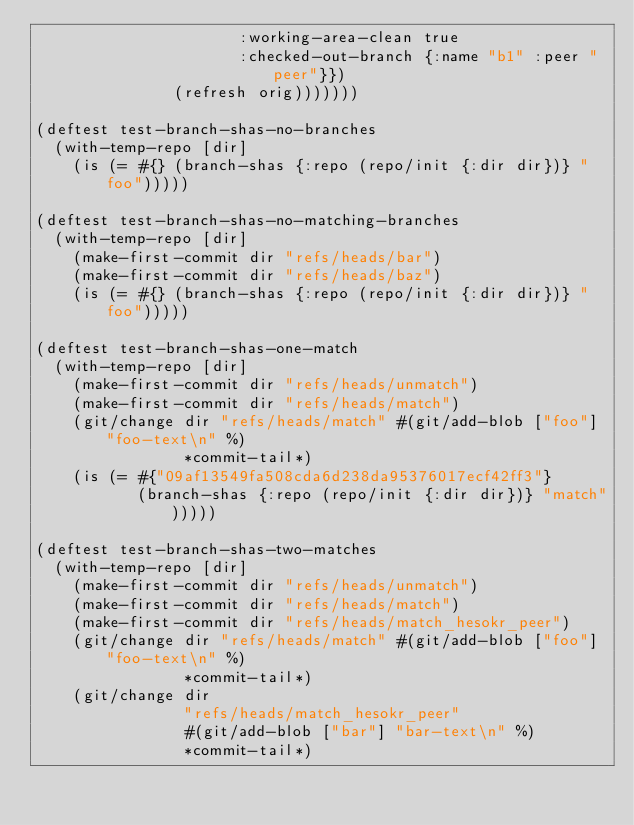Convert code to text. <code><loc_0><loc_0><loc_500><loc_500><_Clojure_>                      :working-area-clean true
                      :checked-out-branch {:name "b1" :peer "peer"}})
               (refresh orig)))))))

(deftest test-branch-shas-no-branches
  (with-temp-repo [dir]
    (is (= #{} (branch-shas {:repo (repo/init {:dir dir})} "foo")))))

(deftest test-branch-shas-no-matching-branches
  (with-temp-repo [dir]
    (make-first-commit dir "refs/heads/bar")
    (make-first-commit dir "refs/heads/baz")
    (is (= #{} (branch-shas {:repo (repo/init {:dir dir})} "foo")))))

(deftest test-branch-shas-one-match
  (with-temp-repo [dir]
    (make-first-commit dir "refs/heads/unmatch")
    (make-first-commit dir "refs/heads/match")
    (git/change dir "refs/heads/match" #(git/add-blob ["foo"] "foo-text\n" %)
                *commit-tail*)
    (is (= #{"09af13549fa508cda6d238da95376017ecf42ff3"}
           (branch-shas {:repo (repo/init {:dir dir})} "match")))))

(deftest test-branch-shas-two-matches
  (with-temp-repo [dir]
    (make-first-commit dir "refs/heads/unmatch")
    (make-first-commit dir "refs/heads/match")
    (make-first-commit dir "refs/heads/match_hesokr_peer")
    (git/change dir "refs/heads/match" #(git/add-blob ["foo"] "foo-text\n" %)
                *commit-tail*)
    (git/change dir
                "refs/heads/match_hesokr_peer"
                #(git/add-blob ["bar"] "bar-text\n" %)
                *commit-tail*)</code> 